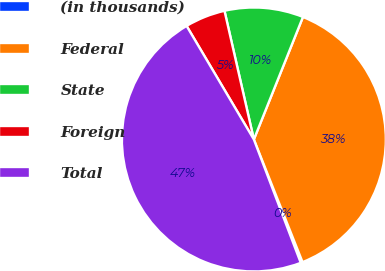<chart> <loc_0><loc_0><loc_500><loc_500><pie_chart><fcel>(in thousands)<fcel>Federal<fcel>State<fcel>Foreign<fcel>Total<nl><fcel>0.23%<fcel>37.92%<fcel>9.64%<fcel>4.94%<fcel>47.27%<nl></chart> 